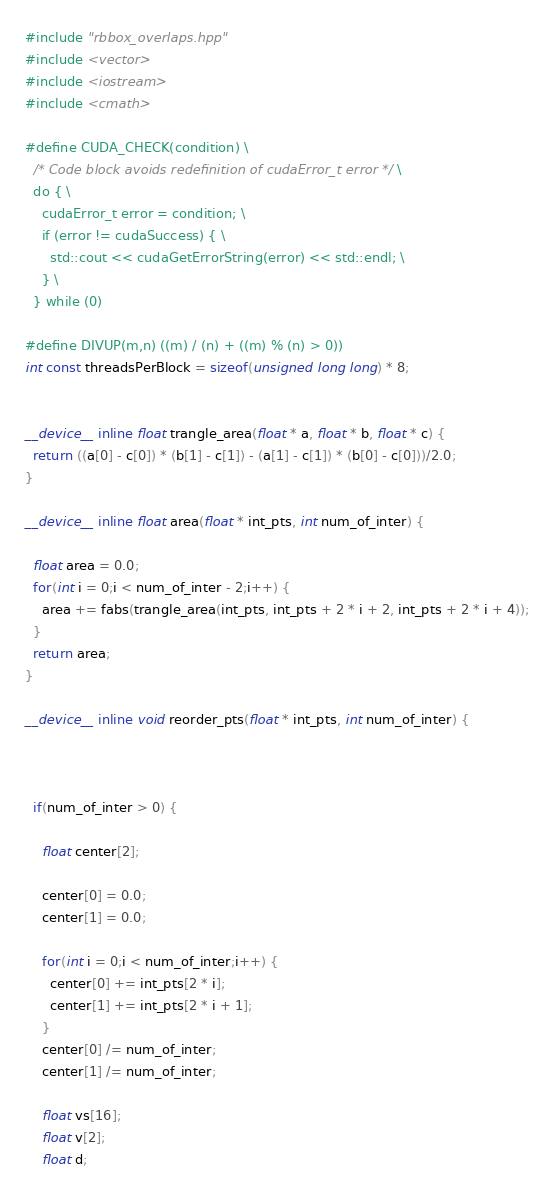<code> <loc_0><loc_0><loc_500><loc_500><_Cuda_>
#include "rbbox_overlaps.hpp"
#include <vector>
#include <iostream>
#include <cmath>

#define CUDA_CHECK(condition) \
  /* Code block avoids redefinition of cudaError_t error */ \
  do { \
    cudaError_t error = condition; \
    if (error != cudaSuccess) { \
      std::cout << cudaGetErrorString(error) << std::endl; \
    } \
  } while (0)

#define DIVUP(m,n) ((m) / (n) + ((m) % (n) > 0))
int const threadsPerBlock = sizeof(unsigned long long) * 8;


__device__ inline float trangle_area(float * a, float * b, float * c) {
  return ((a[0] - c[0]) * (b[1] - c[1]) - (a[1] - c[1]) * (b[0] - c[0]))/2.0;
}

__device__ inline float area(float * int_pts, int num_of_inter) {

  float area = 0.0;
  for(int i = 0;i < num_of_inter - 2;i++) {
    area += fabs(trangle_area(int_pts, int_pts + 2 * i + 2, int_pts + 2 * i + 4));
  }
  return area;
}

__device__ inline void reorder_pts(float * int_pts, int num_of_inter) {



  if(num_of_inter > 0) {
    
    float center[2];
    
    center[0] = 0.0;
    center[1] = 0.0;

    for(int i = 0;i < num_of_inter;i++) {
      center[0] += int_pts[2 * i];
      center[1] += int_pts[2 * i + 1];
    }
    center[0] /= num_of_inter;
    center[1] /= num_of_inter;

    float vs[16];
    float v[2];
    float d;</code> 